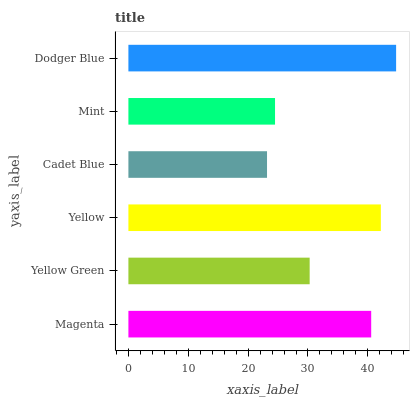Is Cadet Blue the minimum?
Answer yes or no. Yes. Is Dodger Blue the maximum?
Answer yes or no. Yes. Is Yellow Green the minimum?
Answer yes or no. No. Is Yellow Green the maximum?
Answer yes or no. No. Is Magenta greater than Yellow Green?
Answer yes or no. Yes. Is Yellow Green less than Magenta?
Answer yes or no. Yes. Is Yellow Green greater than Magenta?
Answer yes or no. No. Is Magenta less than Yellow Green?
Answer yes or no. No. Is Magenta the high median?
Answer yes or no. Yes. Is Yellow Green the low median?
Answer yes or no. Yes. Is Yellow the high median?
Answer yes or no. No. Is Dodger Blue the low median?
Answer yes or no. No. 